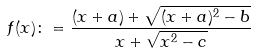<formula> <loc_0><loc_0><loc_500><loc_500>f ( x ) \colon = \frac { ( x + a ) + \sqrt { ( x + a ) ^ { 2 } - b } } { x + \sqrt { x ^ { 2 } - c } }</formula> 